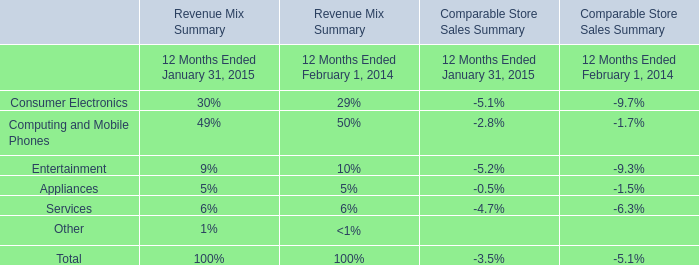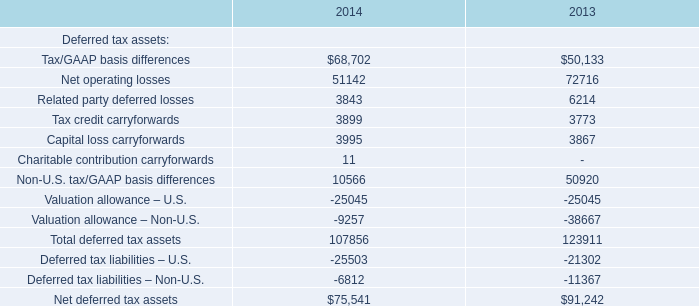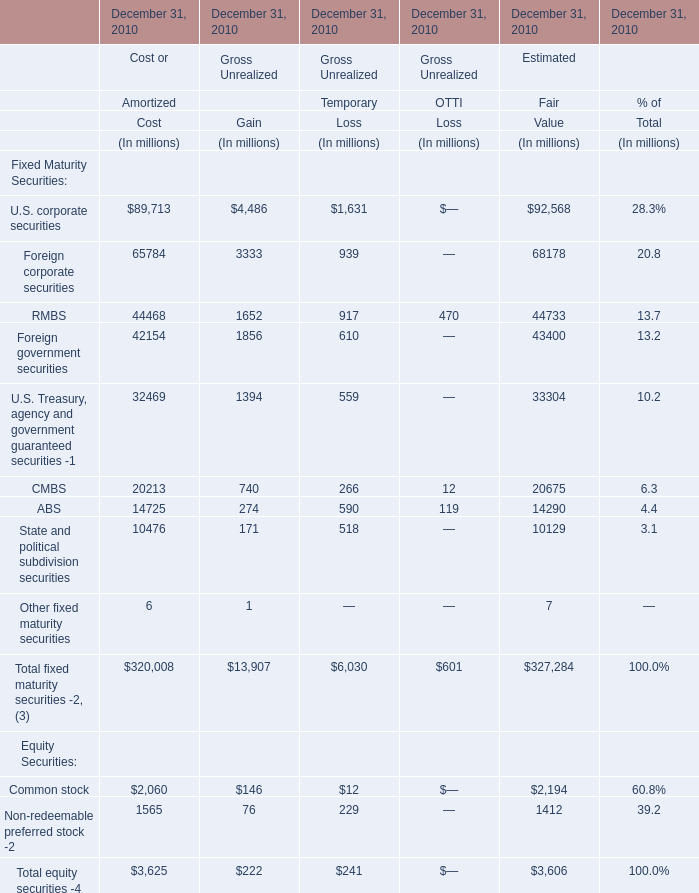Does the value of U.S. corporate securities in Gain greater than that in COST? 
Answer: no. 